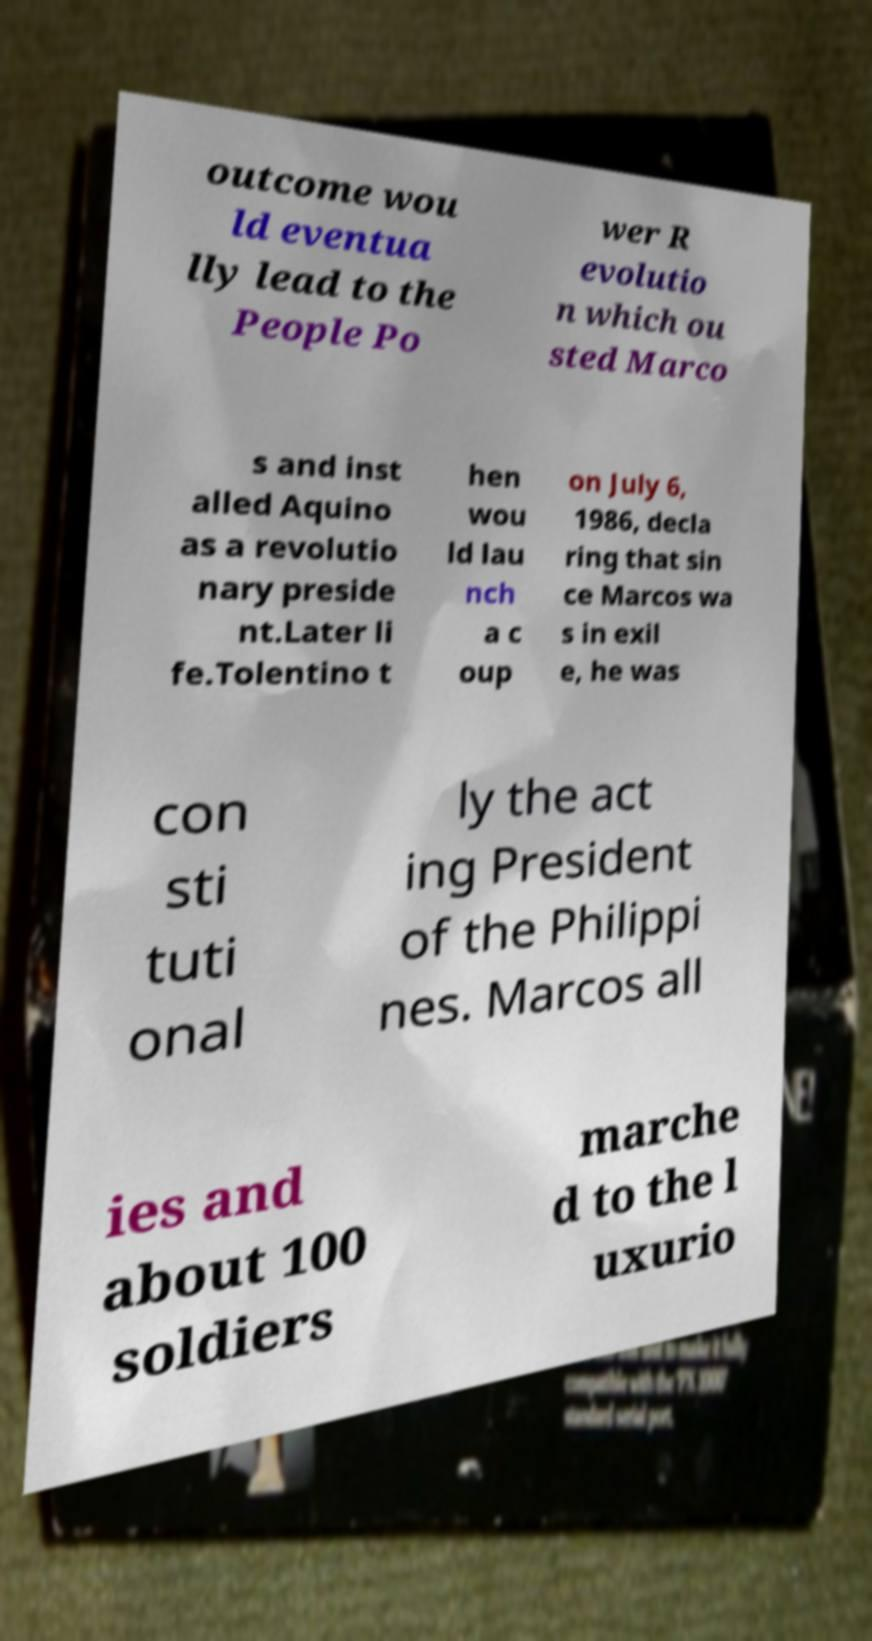What messages or text are displayed in this image? I need them in a readable, typed format. outcome wou ld eventua lly lead to the People Po wer R evolutio n which ou sted Marco s and inst alled Aquino as a revolutio nary preside nt.Later li fe.Tolentino t hen wou ld lau nch a c oup on July 6, 1986, decla ring that sin ce Marcos wa s in exil e, he was con sti tuti onal ly the act ing President of the Philippi nes. Marcos all ies and about 100 soldiers marche d to the l uxurio 